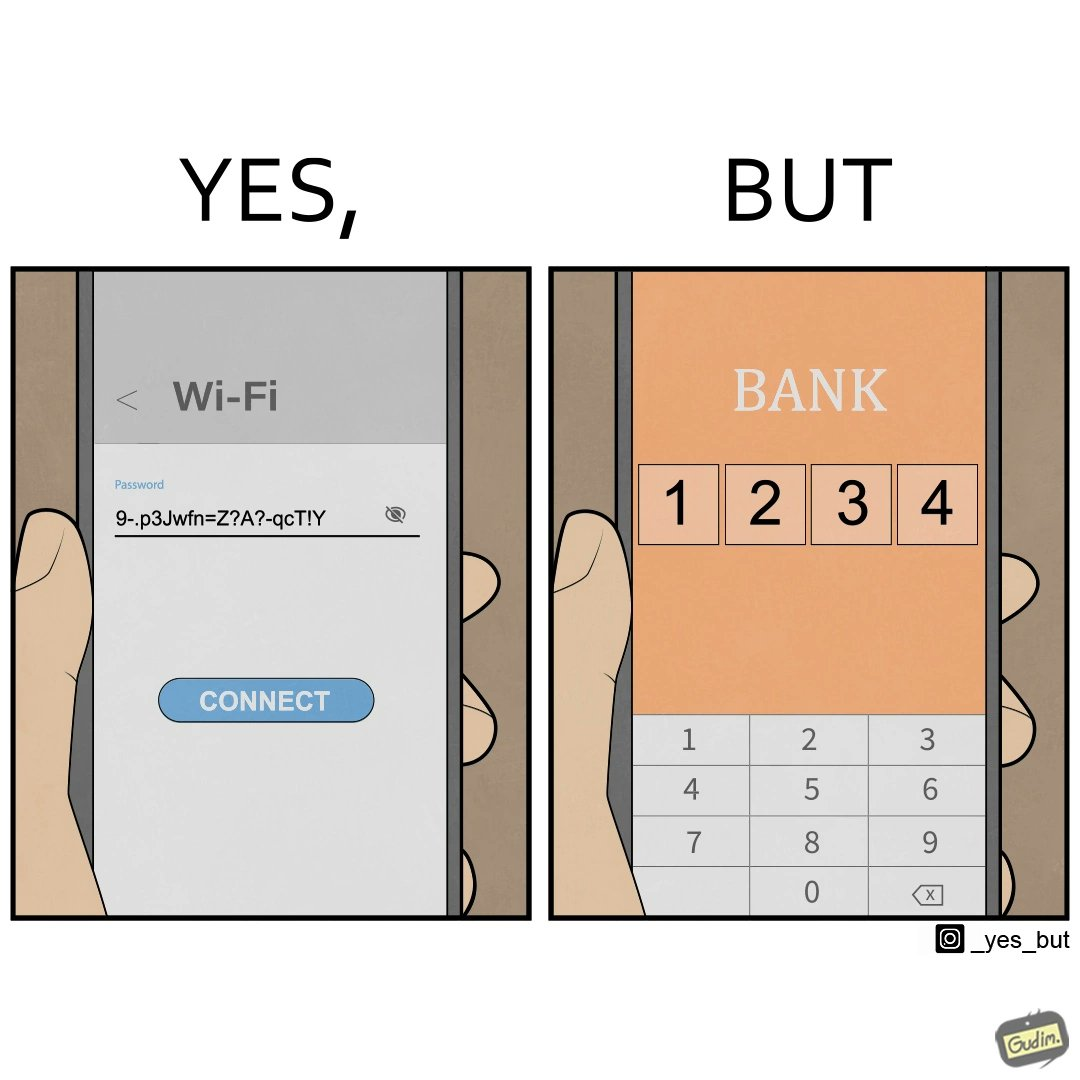Describe what you see in the left and right parts of this image. In the left part of the image: a strong password for connecting Wifi on mobile. In the right part of the image: 4-digit PIN for online banking set to 1234. 